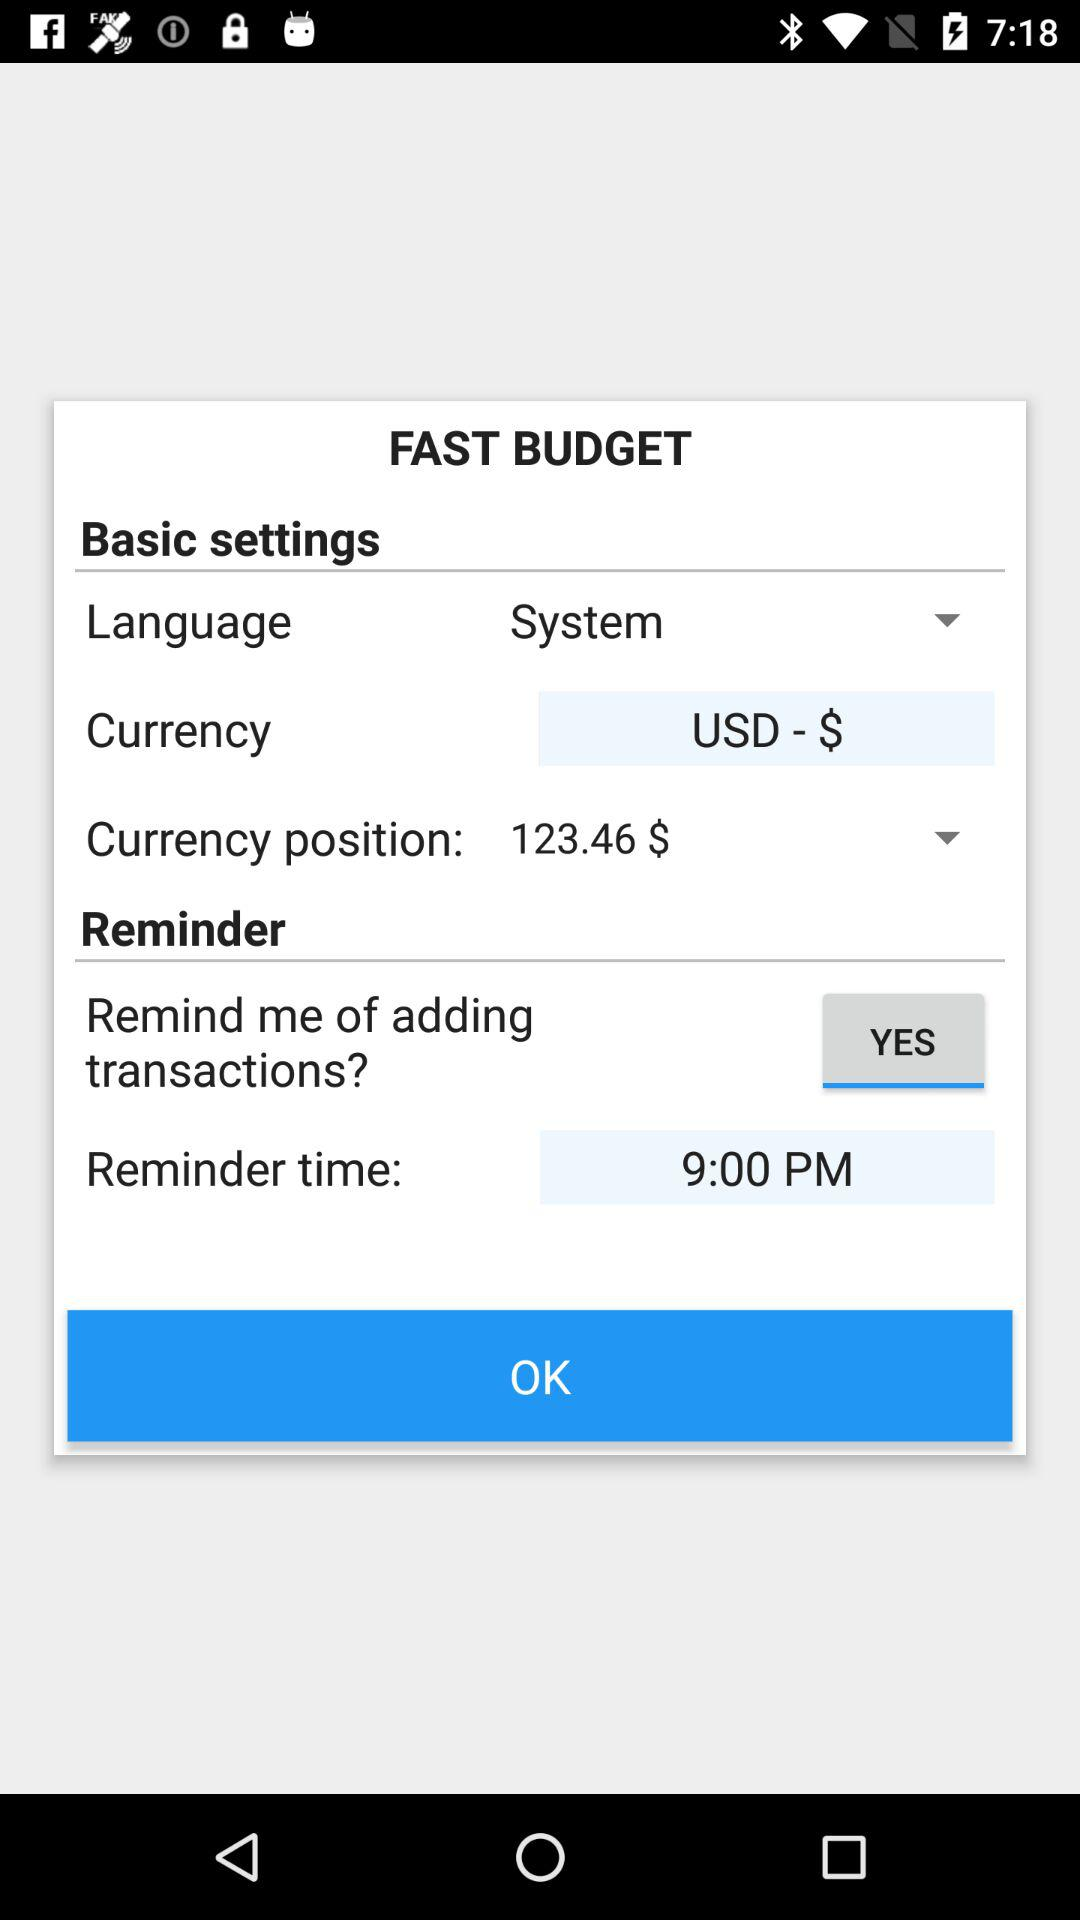What is the status of the "Remind me of adding transactions?" settings? The status is "YES". 